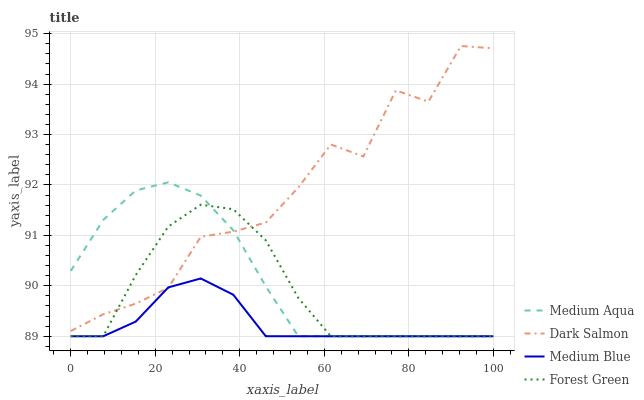Does Medium Blue have the minimum area under the curve?
Answer yes or no. Yes. Does Dark Salmon have the maximum area under the curve?
Answer yes or no. Yes. Does Forest Green have the minimum area under the curve?
Answer yes or no. No. Does Forest Green have the maximum area under the curve?
Answer yes or no. No. Is Medium Blue the smoothest?
Answer yes or no. Yes. Is Dark Salmon the roughest?
Answer yes or no. Yes. Is Forest Green the smoothest?
Answer yes or no. No. Is Forest Green the roughest?
Answer yes or no. No. Does Medium Blue have the lowest value?
Answer yes or no. Yes. Does Dark Salmon have the lowest value?
Answer yes or no. No. Does Dark Salmon have the highest value?
Answer yes or no. Yes. Does Forest Green have the highest value?
Answer yes or no. No. Does Medium Aqua intersect Medium Blue?
Answer yes or no. Yes. Is Medium Aqua less than Medium Blue?
Answer yes or no. No. Is Medium Aqua greater than Medium Blue?
Answer yes or no. No. 